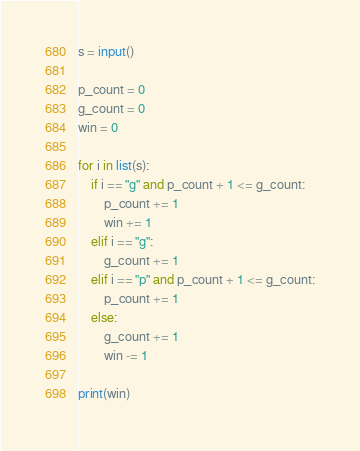<code> <loc_0><loc_0><loc_500><loc_500><_Python_>s = input()

p_count = 0
g_count = 0
win = 0

for i in list(s):
    if i == "g" and p_count + 1 <= g_count:
        p_count += 1
        win += 1
    elif i == "g":
        g_count += 1
    elif i == "p" and p_count + 1 <= g_count:
        p_count += 1
    else:
        g_count += 1
        win -= 1

print(win)
</code> 